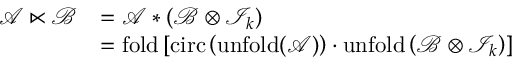<formula> <loc_0><loc_0><loc_500><loc_500>\begin{array} { r l } { \mathcal { A } \ltimes \mathcal { B } } & { = \mathcal { A } \ast \left ( \mathcal { B } \otimes \mathcal { I } _ { k } \right ) } \\ & { = f o l d \left [ c i r c \left ( u n f o l d ( \mathcal { A } ) \right ) \cdot u n f o l d \left ( \mathcal { B } \otimes \mathcal { I } _ { k } \right ) \right ] } \end{array}</formula> 